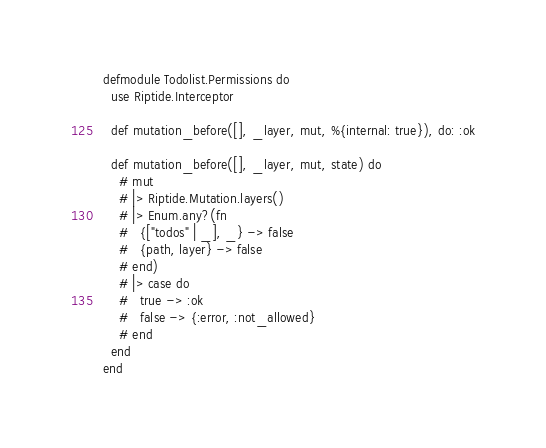Convert code to text. <code><loc_0><loc_0><loc_500><loc_500><_Elixir_>defmodule Todolist.Permissions do
  use Riptide.Interceptor

  def mutation_before([], _layer, mut, %{internal: true}), do: :ok

  def mutation_before([], _layer, mut, state) do
    # mut
    # |> Riptide.Mutation.layers()
    # |> Enum.any?(fn
    #   {["todos" | _], _} -> false
    #   {path, layer} -> false
    # end)
    # |> case do
    #   true -> :ok
    #   false -> {:error, :not_allowed}
    # end
  end
end
</code> 